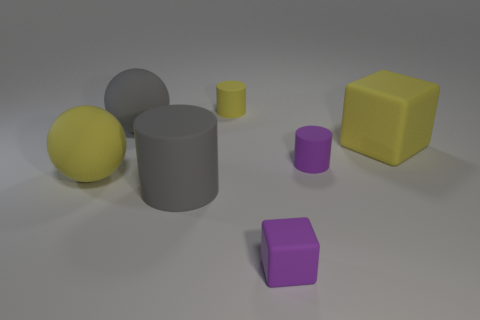Subtract all gray rubber cylinders. How many cylinders are left? 2 Subtract 2 cylinders. How many cylinders are left? 1 Add 1 big blocks. How many objects exist? 8 Subtract all yellow balls. How many balls are left? 1 Subtract all balls. How many objects are left? 5 Subtract 1 yellow cubes. How many objects are left? 6 Subtract all purple balls. Subtract all brown blocks. How many balls are left? 2 Subtract all small yellow objects. Subtract all small matte cubes. How many objects are left? 5 Add 6 small things. How many small things are left? 9 Add 5 purple cylinders. How many purple cylinders exist? 6 